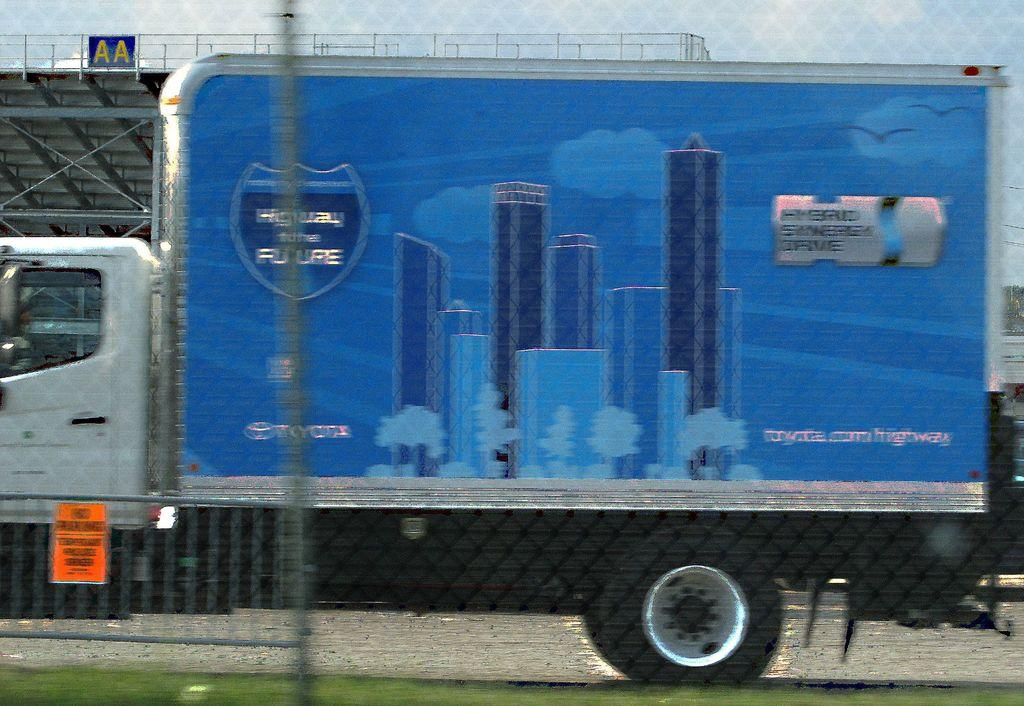What type of surface is visible on the ground in the image? There is grass on the ground in the image. What can be seen on the boards in the image? There are boards with text in the image. What type of vehicle is present in the image? There is a vehicle in the image. What type of barrier is visible in the image? There is fencing in the image. What other objects can be seen in the image besides the grass, boards, vehicle, and fencing? There are other objects in the image. What type of bone is visible in the image? There is no bone present in the image. What verse is written on the boards in the image? The boards in the image contain text, but it is not specified as a verse. 